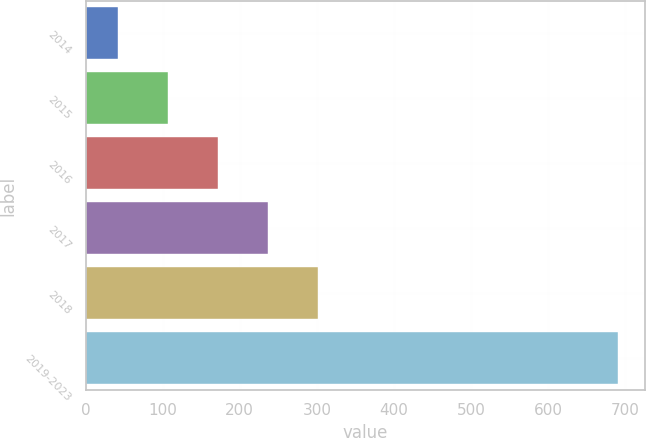Convert chart to OTSL. <chart><loc_0><loc_0><loc_500><loc_500><bar_chart><fcel>2014<fcel>2015<fcel>2016<fcel>2017<fcel>2018<fcel>2019-2023<nl><fcel>42<fcel>106.9<fcel>171.8<fcel>236.7<fcel>301.6<fcel>691<nl></chart> 